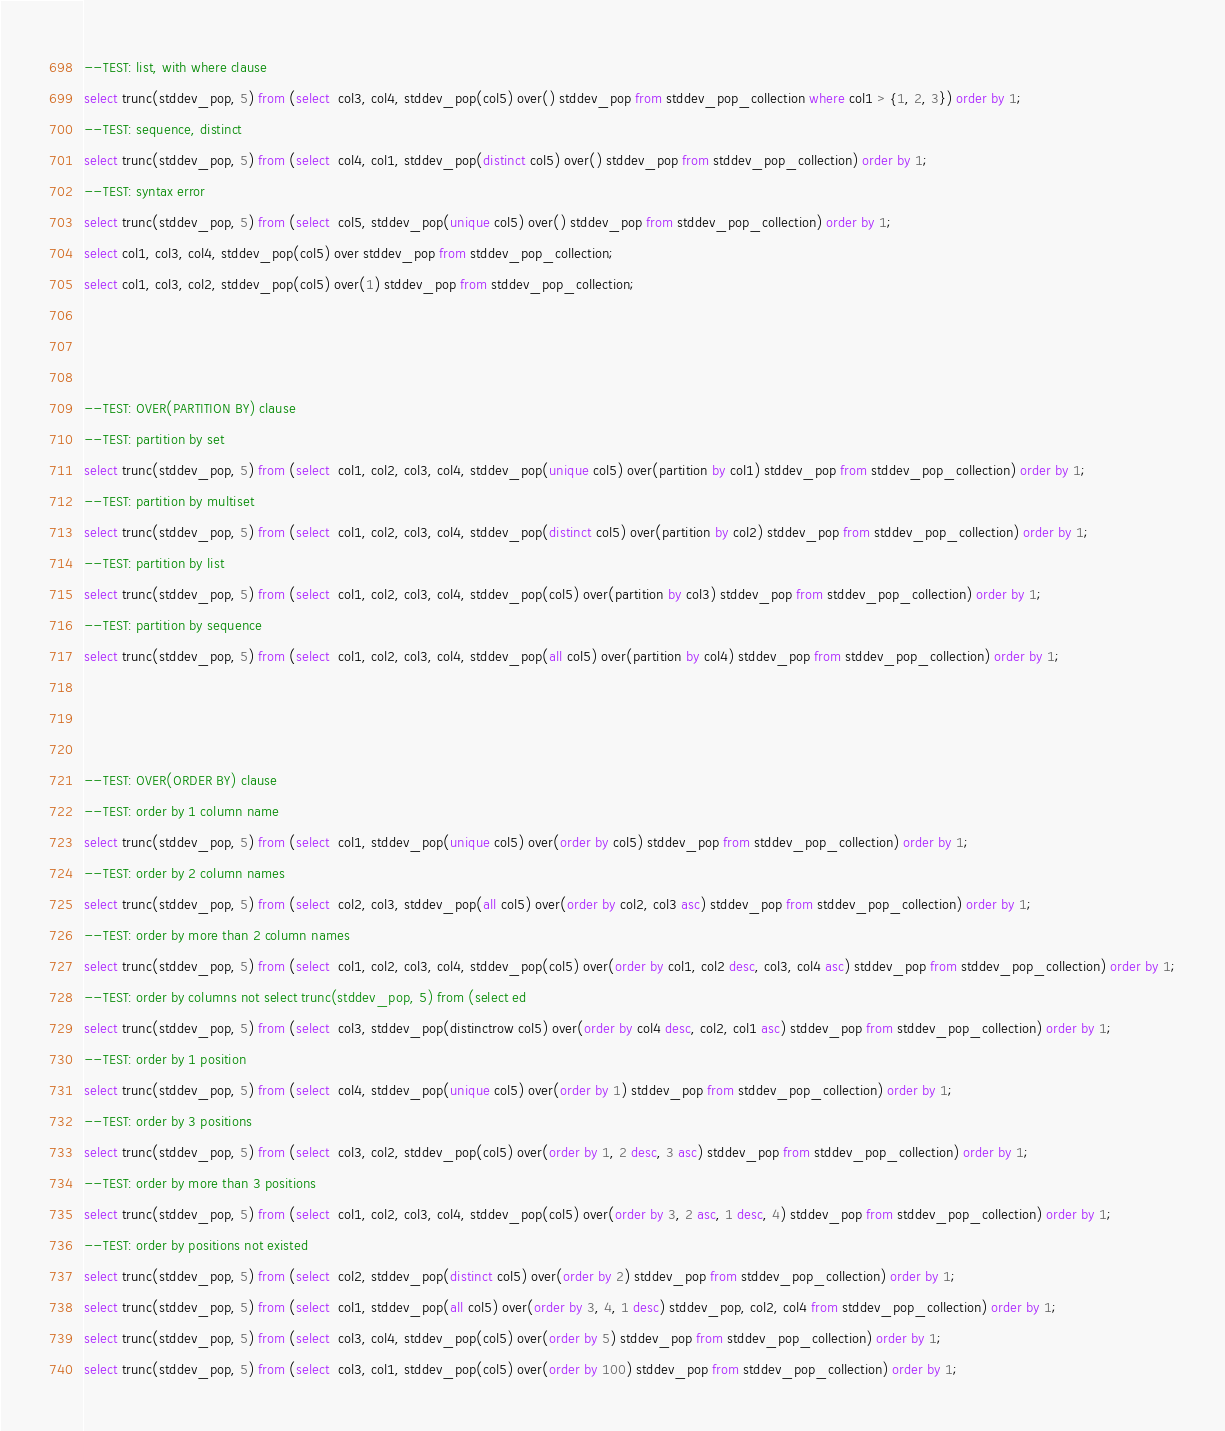Convert code to text. <code><loc_0><loc_0><loc_500><loc_500><_SQL_>--TEST: list, with where clause
select trunc(stddev_pop, 5) from (select  col3, col4, stddev_pop(col5) over() stddev_pop from stddev_pop_collection where col1 > {1, 2, 3}) order by 1;
--TEST: sequence, distinct
select trunc(stddev_pop, 5) from (select  col4, col1, stddev_pop(distinct col5) over() stddev_pop from stddev_pop_collection) order by 1;
--TEST: syntax error
select trunc(stddev_pop, 5) from (select  col5, stddev_pop(unique col5) over() stddev_pop from stddev_pop_collection) order by 1;
select col1, col3, col4, stddev_pop(col5) over stddev_pop from stddev_pop_collection;
select col1, col3, col2, stddev_pop(col5) over(1) stddev_pop from stddev_pop_collection;



--TEST: OVER(PARTITION BY) clause
--TEST: partition by set
select trunc(stddev_pop, 5) from (select  col1, col2, col3, col4, stddev_pop(unique col5) over(partition by col1) stddev_pop from stddev_pop_collection) order by 1;
--TEST: partition by multiset
select trunc(stddev_pop, 5) from (select  col1, col2, col3, col4, stddev_pop(distinct col5) over(partition by col2) stddev_pop from stddev_pop_collection) order by 1;
--TEST: partition by list
select trunc(stddev_pop, 5) from (select  col1, col2, col3, col4, stddev_pop(col5) over(partition by col3) stddev_pop from stddev_pop_collection) order by 1;
--TEST: partition by sequence
select trunc(stddev_pop, 5) from (select  col1, col2, col3, col4, stddev_pop(all col5) over(partition by col4) stddev_pop from stddev_pop_collection) order by 1;



--TEST: OVER(ORDER BY) clause
--TEST: order by 1 column name
select trunc(stddev_pop, 5) from (select  col1, stddev_pop(unique col5) over(order by col5) stddev_pop from stddev_pop_collection) order by 1;
--TEST: order by 2 column names
select trunc(stddev_pop, 5) from (select  col2, col3, stddev_pop(all col5) over(order by col2, col3 asc) stddev_pop from stddev_pop_collection) order by 1;
--TEST: order by more than 2 column names
select trunc(stddev_pop, 5) from (select  col1, col2, col3, col4, stddev_pop(col5) over(order by col1, col2 desc, col3, col4 asc) stddev_pop from stddev_pop_collection) order by 1;
--TEST: order by columns not select trunc(stddev_pop, 5) from (select ed
select trunc(stddev_pop, 5) from (select  col3, stddev_pop(distinctrow col5) over(order by col4 desc, col2, col1 asc) stddev_pop from stddev_pop_collection) order by 1;
--TEST: order by 1 position
select trunc(stddev_pop, 5) from (select  col4, stddev_pop(unique col5) over(order by 1) stddev_pop from stddev_pop_collection) order by 1;
--TEST: order by 3 positions
select trunc(stddev_pop, 5) from (select  col3, col2, stddev_pop(col5) over(order by 1, 2 desc, 3 asc) stddev_pop from stddev_pop_collection) order by 1;
--TEST: order by more than 3 positions
select trunc(stddev_pop, 5) from (select  col1, col2, col3, col4, stddev_pop(col5) over(order by 3, 2 asc, 1 desc, 4) stddev_pop from stddev_pop_collection) order by 1;
--TEST: order by positions not existed
select trunc(stddev_pop, 5) from (select  col2, stddev_pop(distinct col5) over(order by 2) stddev_pop from stddev_pop_collection) order by 1;
select trunc(stddev_pop, 5) from (select  col1, stddev_pop(all col5) over(order by 3, 4, 1 desc) stddev_pop, col2, col4 from stddev_pop_collection) order by 1;
select trunc(stddev_pop, 5) from (select  col3, col4, stddev_pop(col5) over(order by 5) stddev_pop from stddev_pop_collection) order by 1;
select trunc(stddev_pop, 5) from (select  col3, col1, stddev_pop(col5) over(order by 100) stddev_pop from stddev_pop_collection) order by 1;</code> 